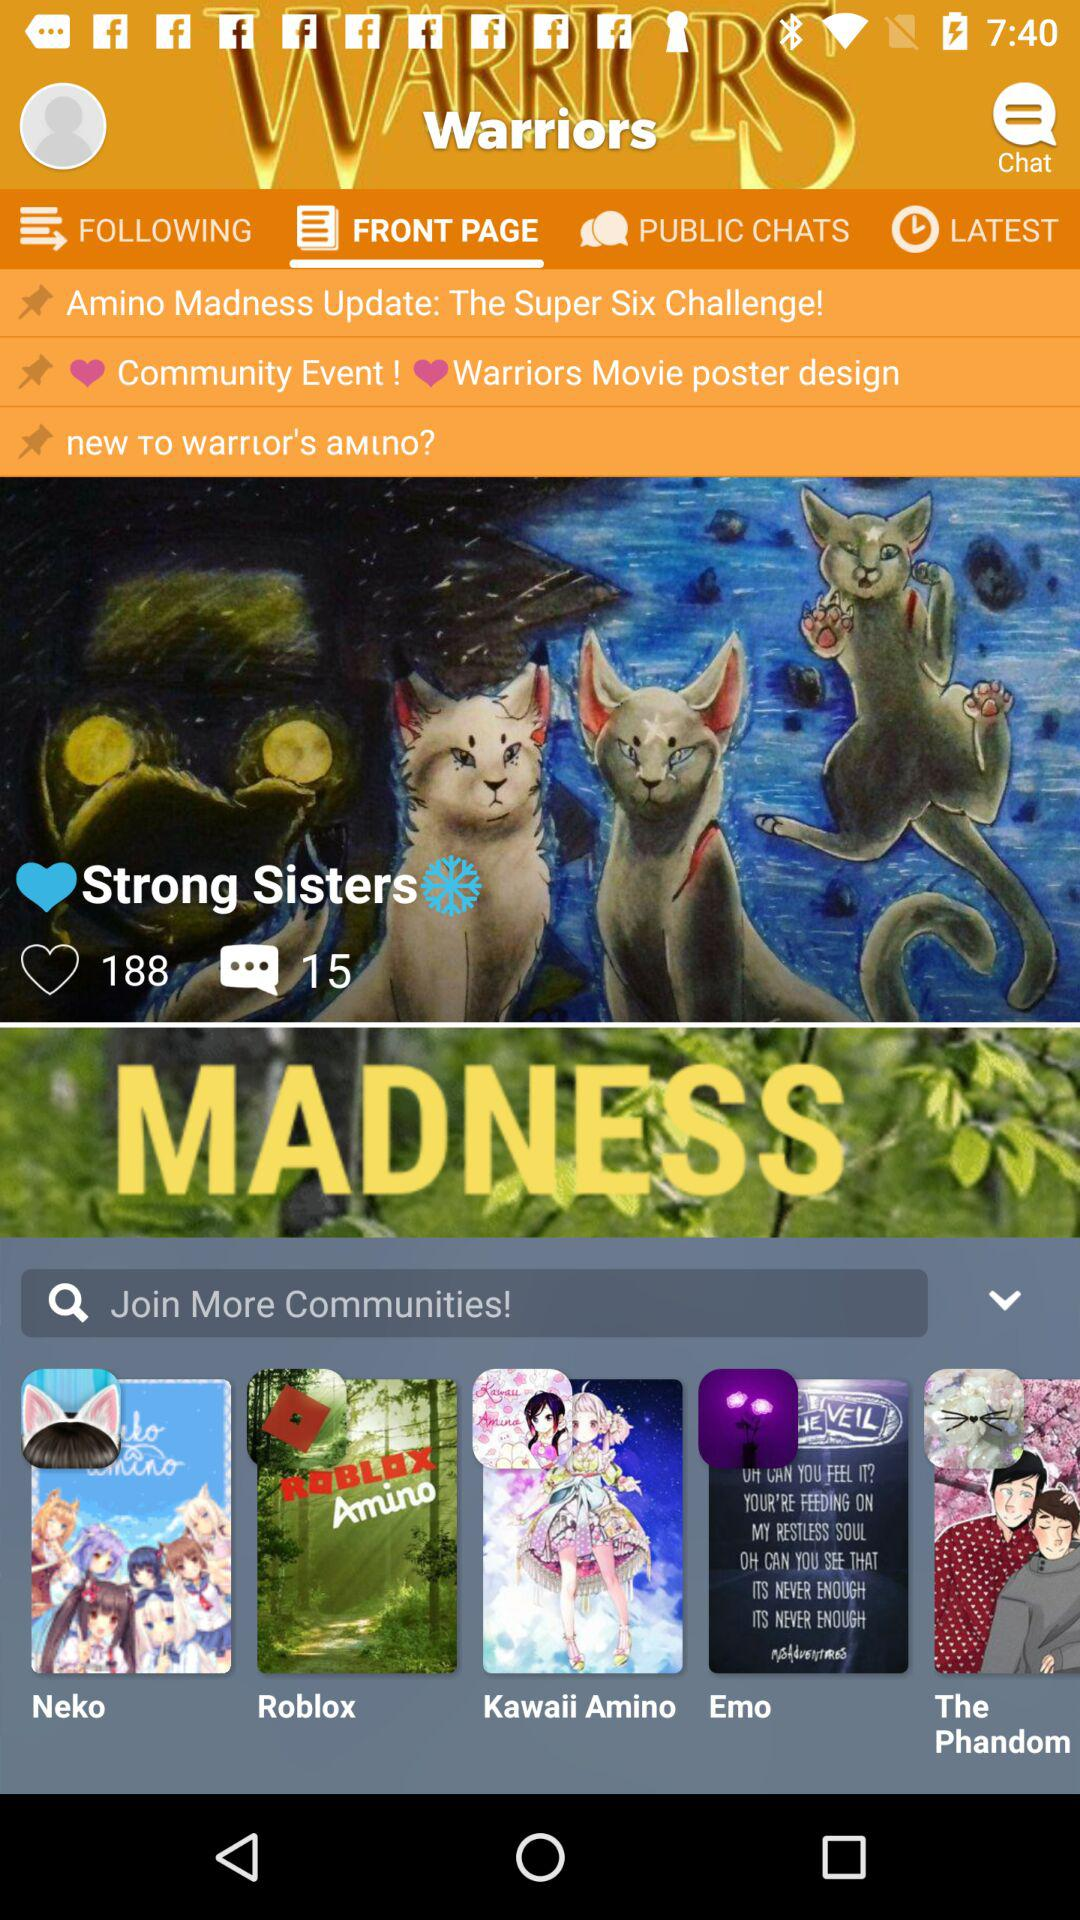How many likes did "Strong Sisters" have? "Strong Sisters" got 188 likes. 